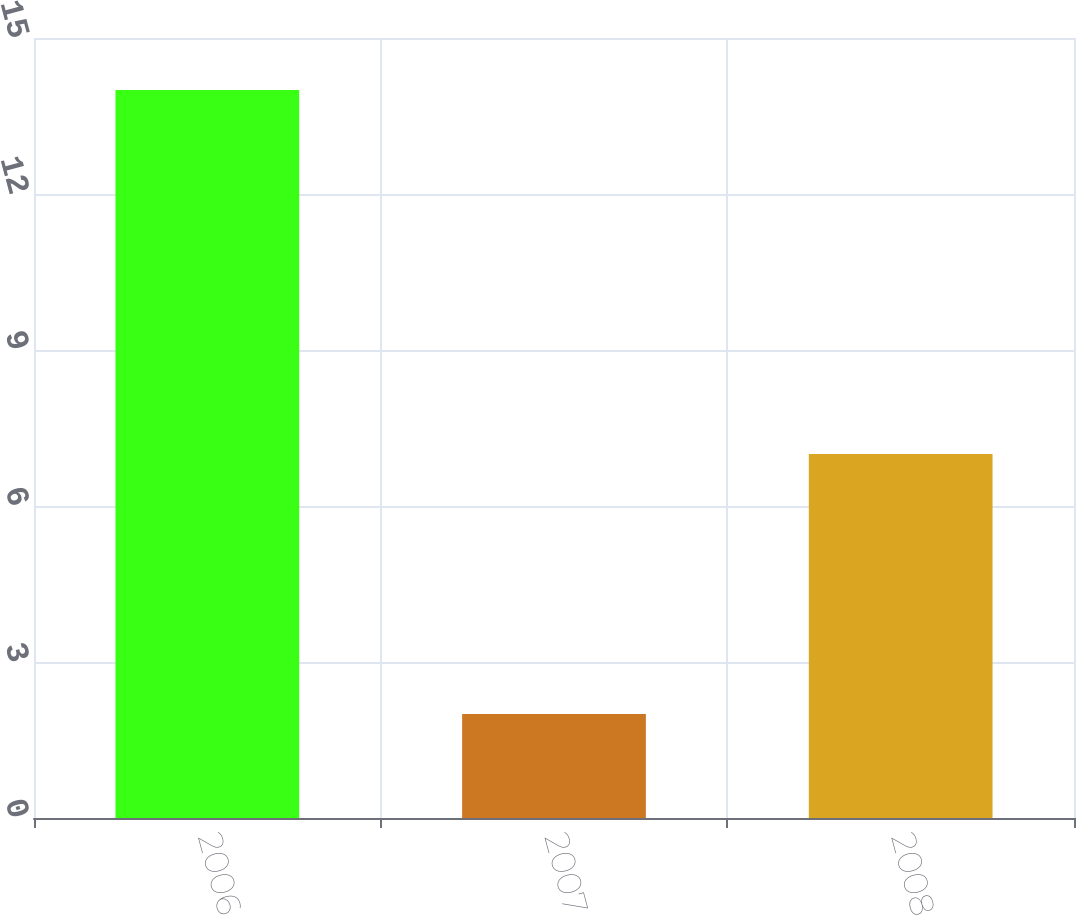<chart> <loc_0><loc_0><loc_500><loc_500><bar_chart><fcel>2006<fcel>2007<fcel>2008<nl><fcel>14<fcel>2<fcel>7<nl></chart> 